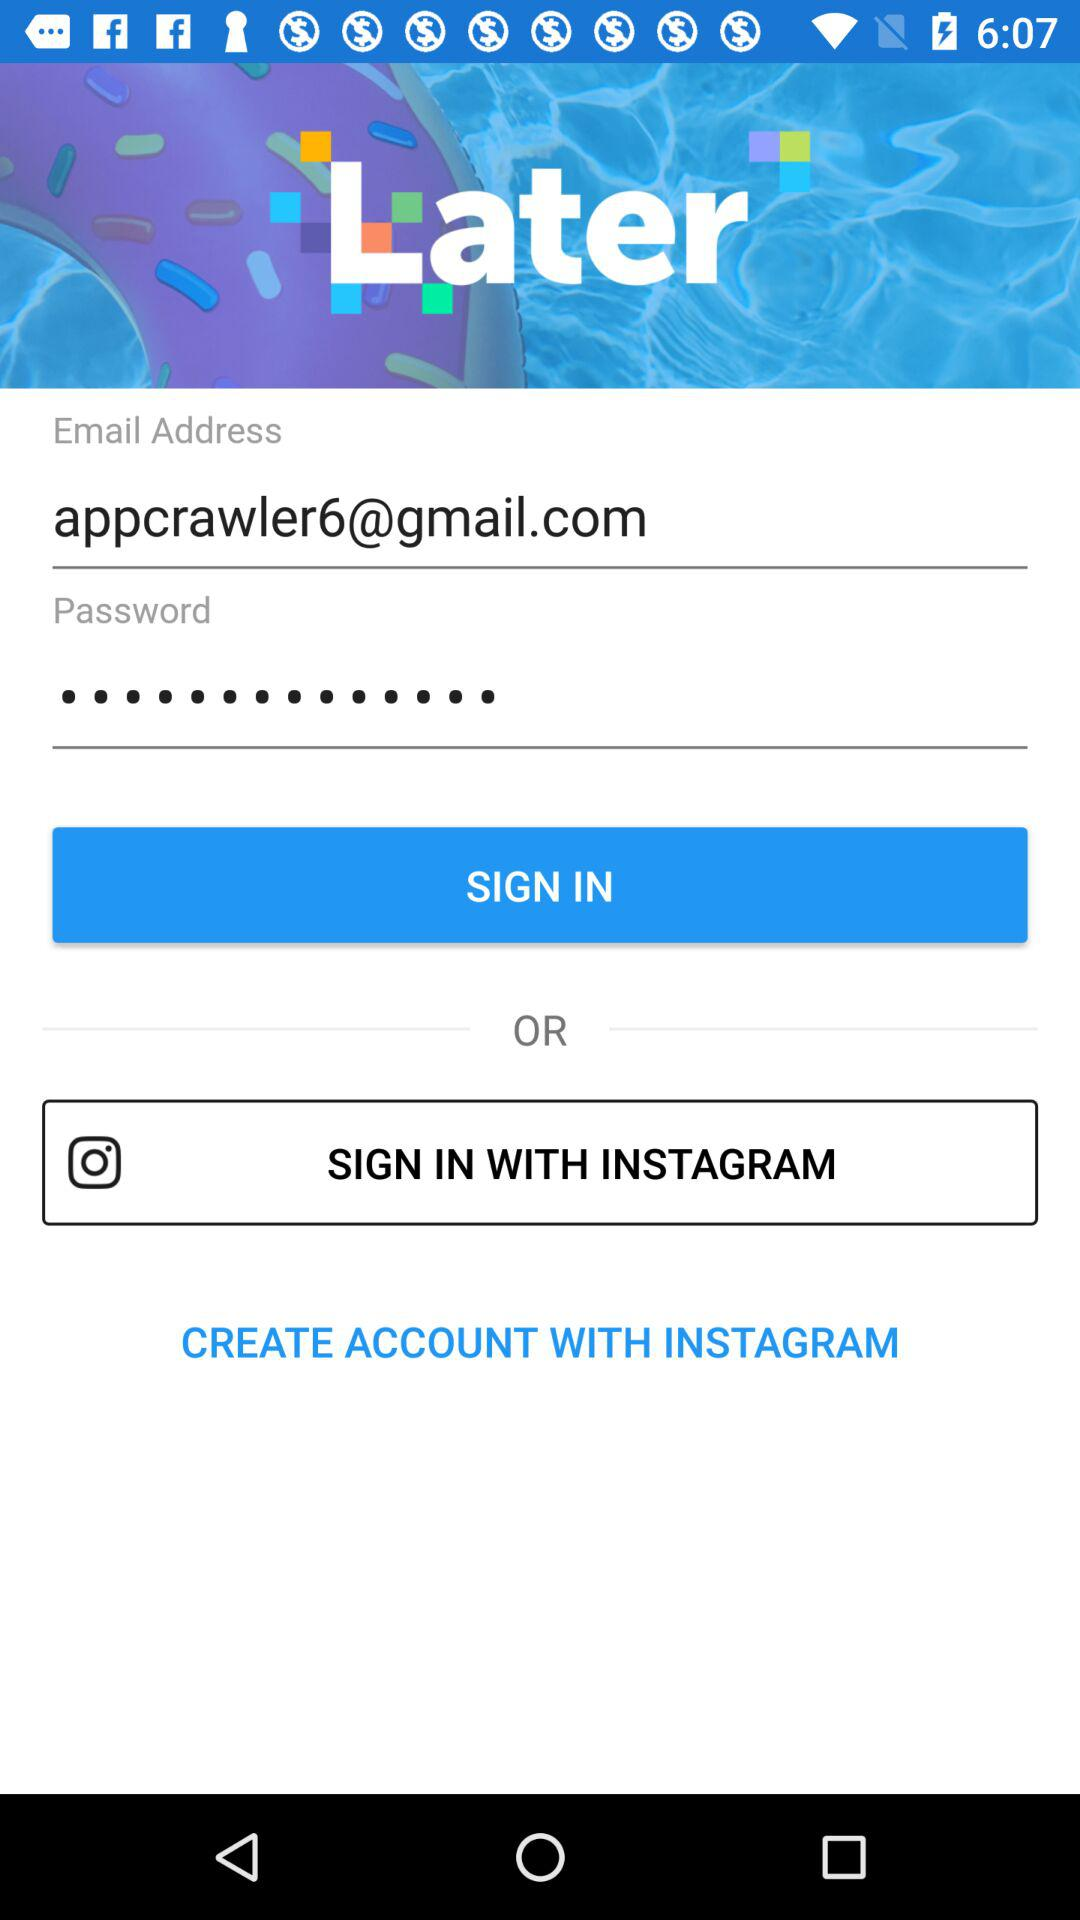What is the name of the application? The name of the application is "Later". 